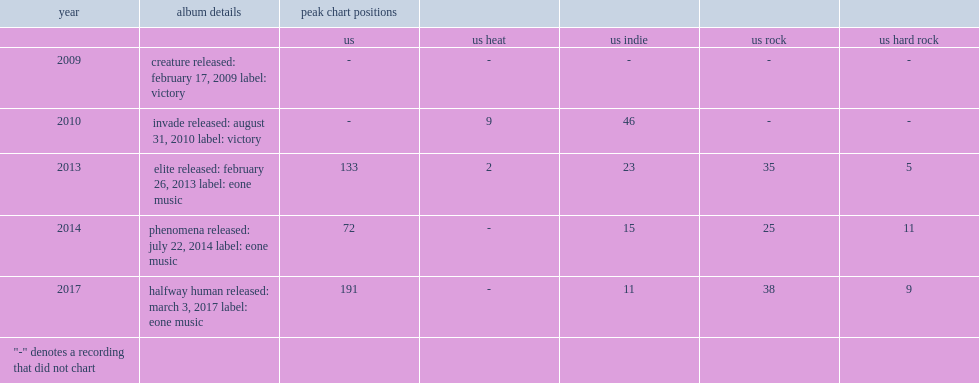How many peak chart positions did within the ruins peaked at number? 191.0. 